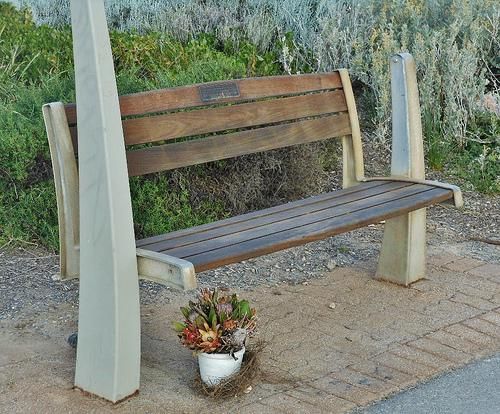Question: when was this pic taken?
Choices:
A. During breakfast.
B. At wedding.
C. Sunset.
D. During the daytime.
Answer with the letter. Answer: D Question: what is this a pic of?
Choices:
A. A family.
B. A house.
C. A garden.
D. A park bench.
Answer with the letter. Answer: D Question: how many slates of wood are there?
Choices:
A. 7.
B. 8.
C. 9.
D. 6.
Answer with the letter. Answer: A Question: where is is the flower pot?
Choices:
A. Window sill.
B. Beneth the bench.
C. On table.
D. On the patio.
Answer with the letter. Answer: B Question: what is the base made from?
Choices:
A. Brick pavers.
B. Stone.
C. Bamboo.
D. Steel.
Answer with the letter. Answer: A 